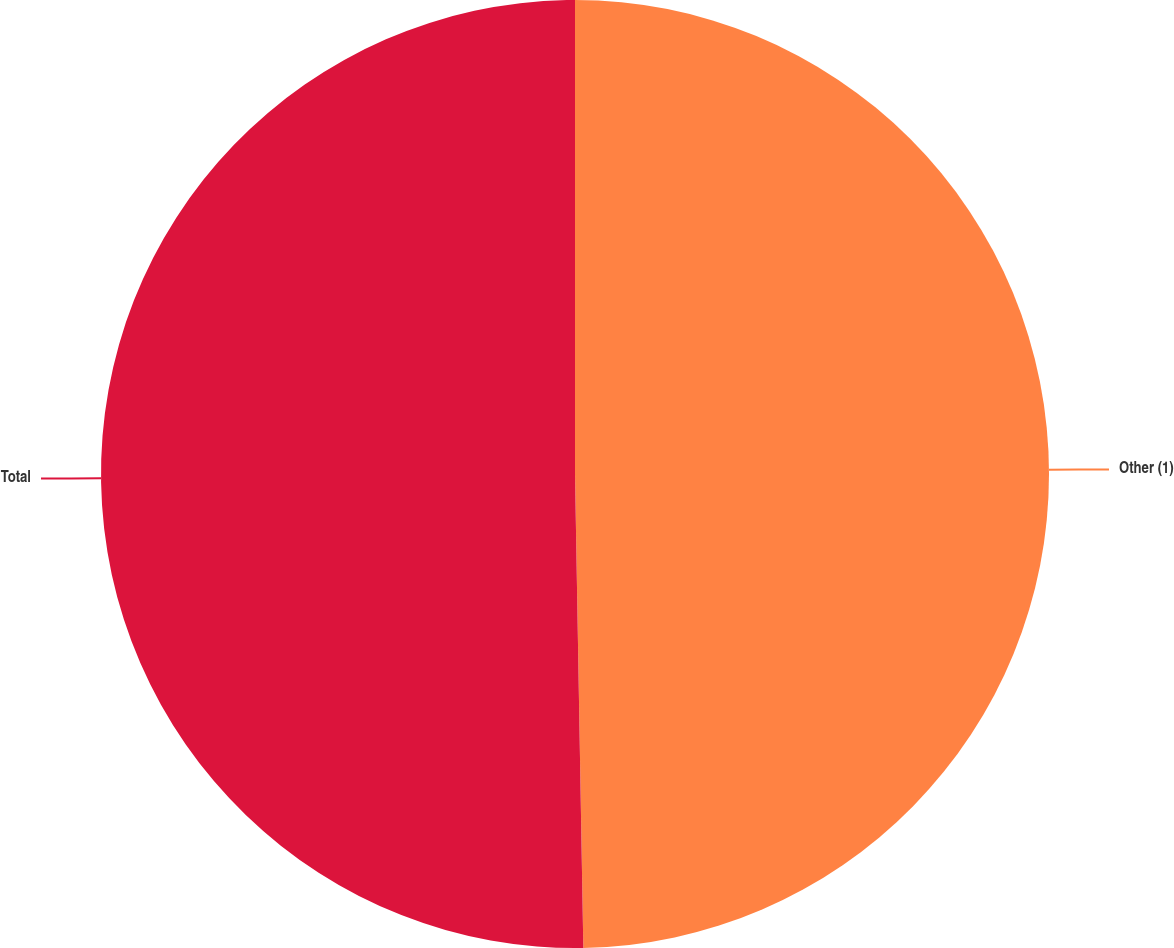Convert chart. <chart><loc_0><loc_0><loc_500><loc_500><pie_chart><fcel>Other (1)<fcel>Total<nl><fcel>49.72%<fcel>50.28%<nl></chart> 